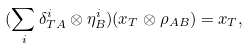<formula> <loc_0><loc_0><loc_500><loc_500>( \sum _ { i } \delta ^ { i } _ { T A } \otimes \eta ^ { i } _ { B } ) ( x _ { T } \otimes \rho _ { A B } ) = x _ { T } ,</formula> 